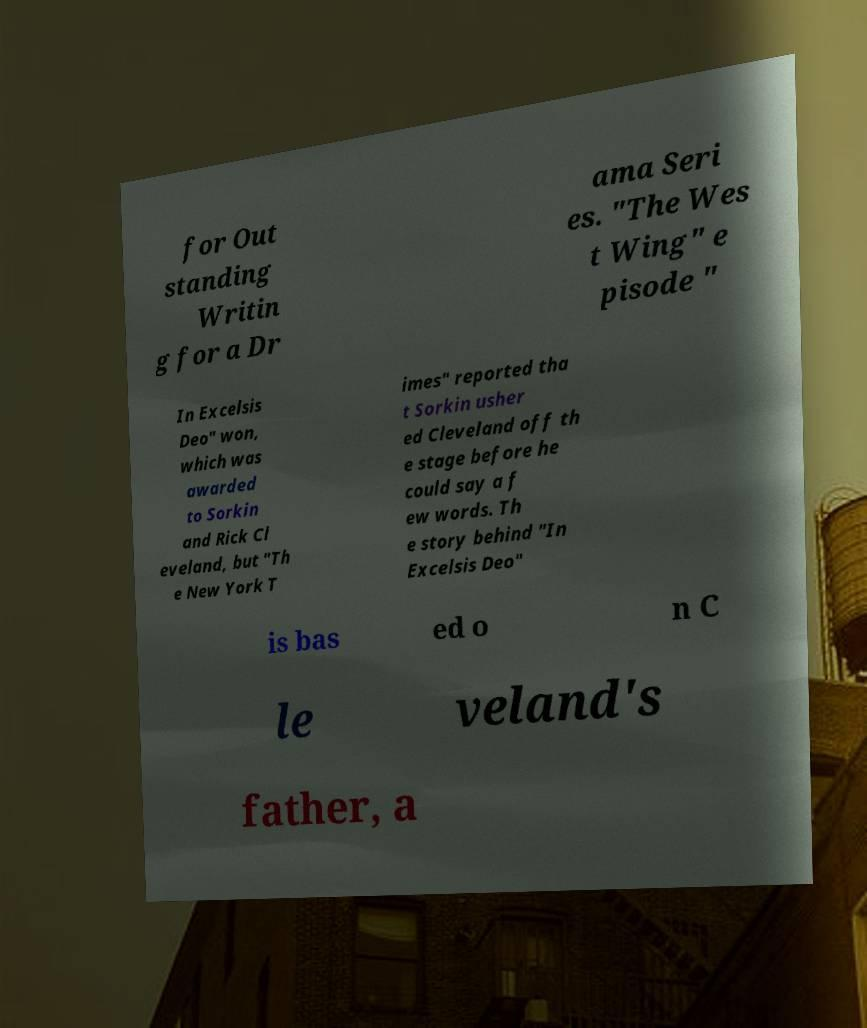For documentation purposes, I need the text within this image transcribed. Could you provide that? for Out standing Writin g for a Dr ama Seri es. "The Wes t Wing" e pisode " In Excelsis Deo" won, which was awarded to Sorkin and Rick Cl eveland, but "Th e New York T imes" reported tha t Sorkin usher ed Cleveland off th e stage before he could say a f ew words. Th e story behind "In Excelsis Deo" is bas ed o n C le veland's father, a 